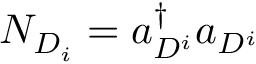<formula> <loc_0><loc_0><loc_500><loc_500>N _ { D _ { i } } = a _ { D ^ { i } } ^ { \dagger } a _ { D ^ { i } }</formula> 